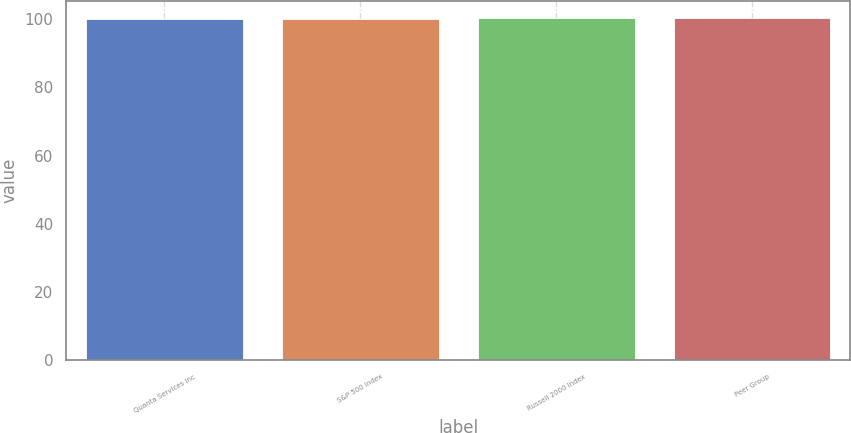Convert chart. <chart><loc_0><loc_0><loc_500><loc_500><bar_chart><fcel>Quanta Services Inc<fcel>S&P 500 Index<fcel>Russell 2000 Index<fcel>Peer Group<nl><fcel>100<fcel>100.1<fcel>100.2<fcel>100.3<nl></chart> 